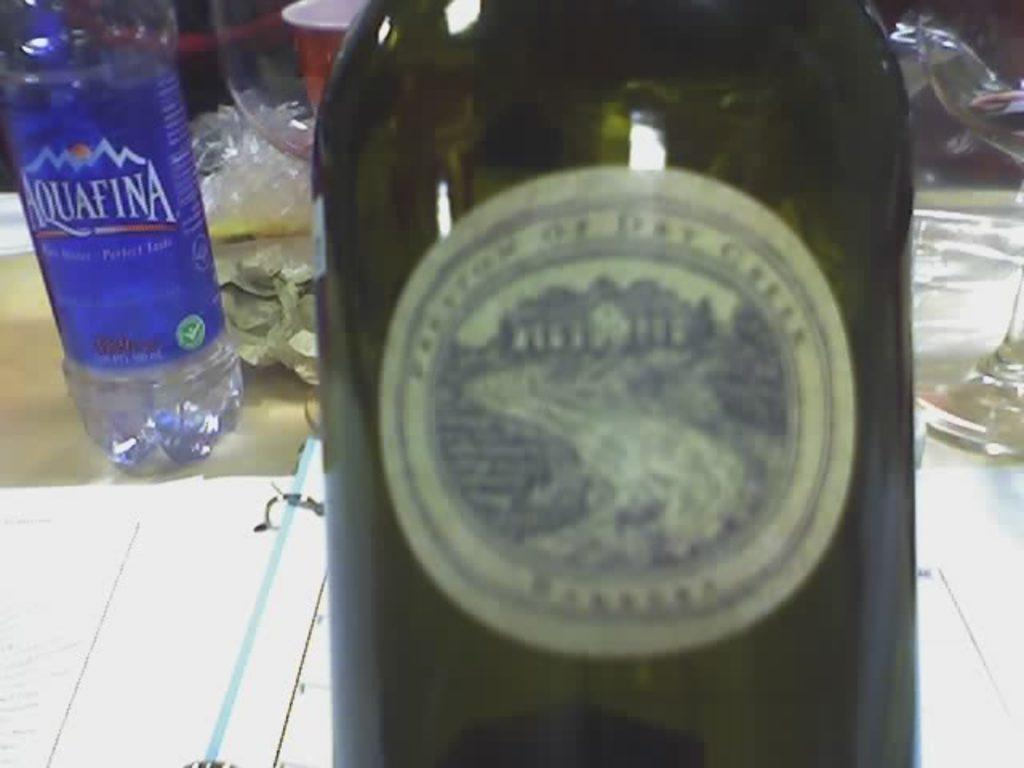What type of beverages can be seen in the image? There is a bottle of wine and a bottle of water in the image. What is used for drinking in the image? There is a glass in the image. Where are the items placed in the image? All the items mentioned are placed on a table. What type of document is present in the image? There is a file of papers in the image. What color is the rose on the table in the image? There is no rose present in the image. How does the dog in the image help with the cough? There is no dog or cough present in the image. 